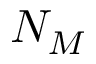<formula> <loc_0><loc_0><loc_500><loc_500>N _ { M }</formula> 